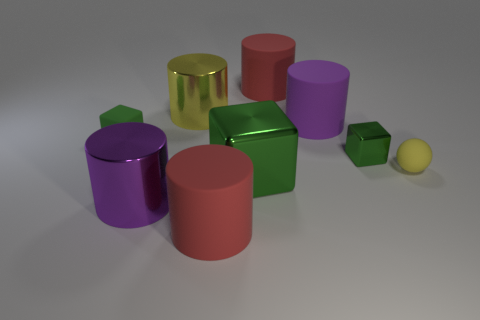Are there any other tiny things that have the same shape as the small metallic thing?
Your answer should be compact. Yes. There is a red object that is behind the yellow rubber thing; how big is it?
Make the answer very short. Large. What material is the sphere that is the same size as the green matte cube?
Provide a succinct answer. Rubber. Are there more big cylinders than yellow matte cubes?
Your answer should be very brief. Yes. There is a purple cylinder in front of the green block that is in front of the tiny yellow rubber object; how big is it?
Keep it short and to the point. Large. The yellow matte thing that is the same size as the green rubber object is what shape?
Ensure brevity in your answer.  Sphere. What shape is the red thing that is in front of the large shiny cylinder to the right of the big purple object that is in front of the green rubber thing?
Give a very brief answer. Cylinder. Do the big metal cylinder that is right of the large purple metallic cylinder and the small matte thing to the left of the small green metallic object have the same color?
Keep it short and to the point. No. What number of big matte cylinders are there?
Provide a short and direct response. 3. Are there any yellow shiny cylinders on the right side of the large yellow cylinder?
Your answer should be compact. No. 